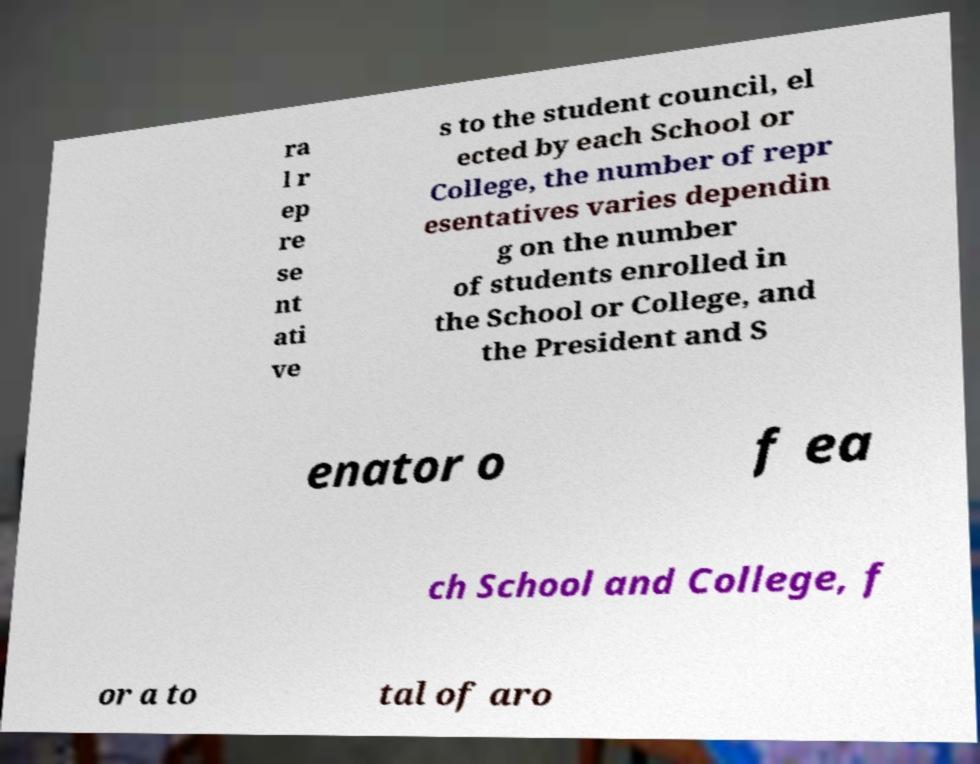There's text embedded in this image that I need extracted. Can you transcribe it verbatim? ra l r ep re se nt ati ve s to the student council, el ected by each School or College, the number of repr esentatives varies dependin g on the number of students enrolled in the School or College, and the President and S enator o f ea ch School and College, f or a to tal of aro 